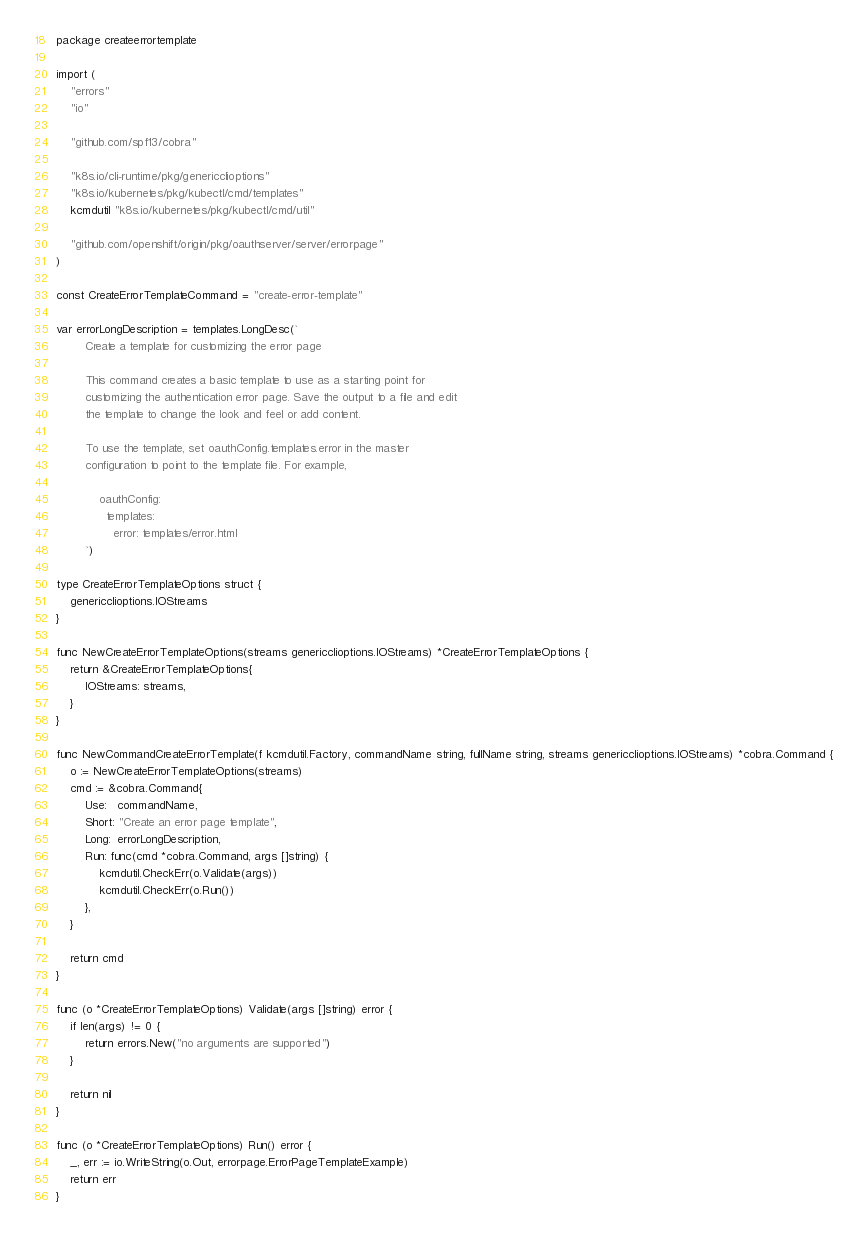Convert code to text. <code><loc_0><loc_0><loc_500><loc_500><_Go_>package createerrortemplate

import (
	"errors"
	"io"

	"github.com/spf13/cobra"

	"k8s.io/cli-runtime/pkg/genericclioptions"
	"k8s.io/kubernetes/pkg/kubectl/cmd/templates"
	kcmdutil "k8s.io/kubernetes/pkg/kubectl/cmd/util"

	"github.com/openshift/origin/pkg/oauthserver/server/errorpage"
)

const CreateErrorTemplateCommand = "create-error-template"

var errorLongDescription = templates.LongDesc(`
		Create a template for customizing the error page

		This command creates a basic template to use as a starting point for
		customizing the authentication error page. Save the output to a file and edit
		the template to change the look and feel or add content.

		To use the template, set oauthConfig.templates.error in the master
		configuration to point to the template file. For example,

		    oauthConfig:
		      templates:
		        error: templates/error.html
		`)

type CreateErrorTemplateOptions struct {
	genericclioptions.IOStreams
}

func NewCreateErrorTemplateOptions(streams genericclioptions.IOStreams) *CreateErrorTemplateOptions {
	return &CreateErrorTemplateOptions{
		IOStreams: streams,
	}
}

func NewCommandCreateErrorTemplate(f kcmdutil.Factory, commandName string, fullName string, streams genericclioptions.IOStreams) *cobra.Command {
	o := NewCreateErrorTemplateOptions(streams)
	cmd := &cobra.Command{
		Use:   commandName,
		Short: "Create an error page template",
		Long:  errorLongDescription,
		Run: func(cmd *cobra.Command, args []string) {
			kcmdutil.CheckErr(o.Validate(args))
			kcmdutil.CheckErr(o.Run())
		},
	}

	return cmd
}

func (o *CreateErrorTemplateOptions) Validate(args []string) error {
	if len(args) != 0 {
		return errors.New("no arguments are supported")
	}

	return nil
}

func (o *CreateErrorTemplateOptions) Run() error {
	_, err := io.WriteString(o.Out, errorpage.ErrorPageTemplateExample)
	return err
}
</code> 